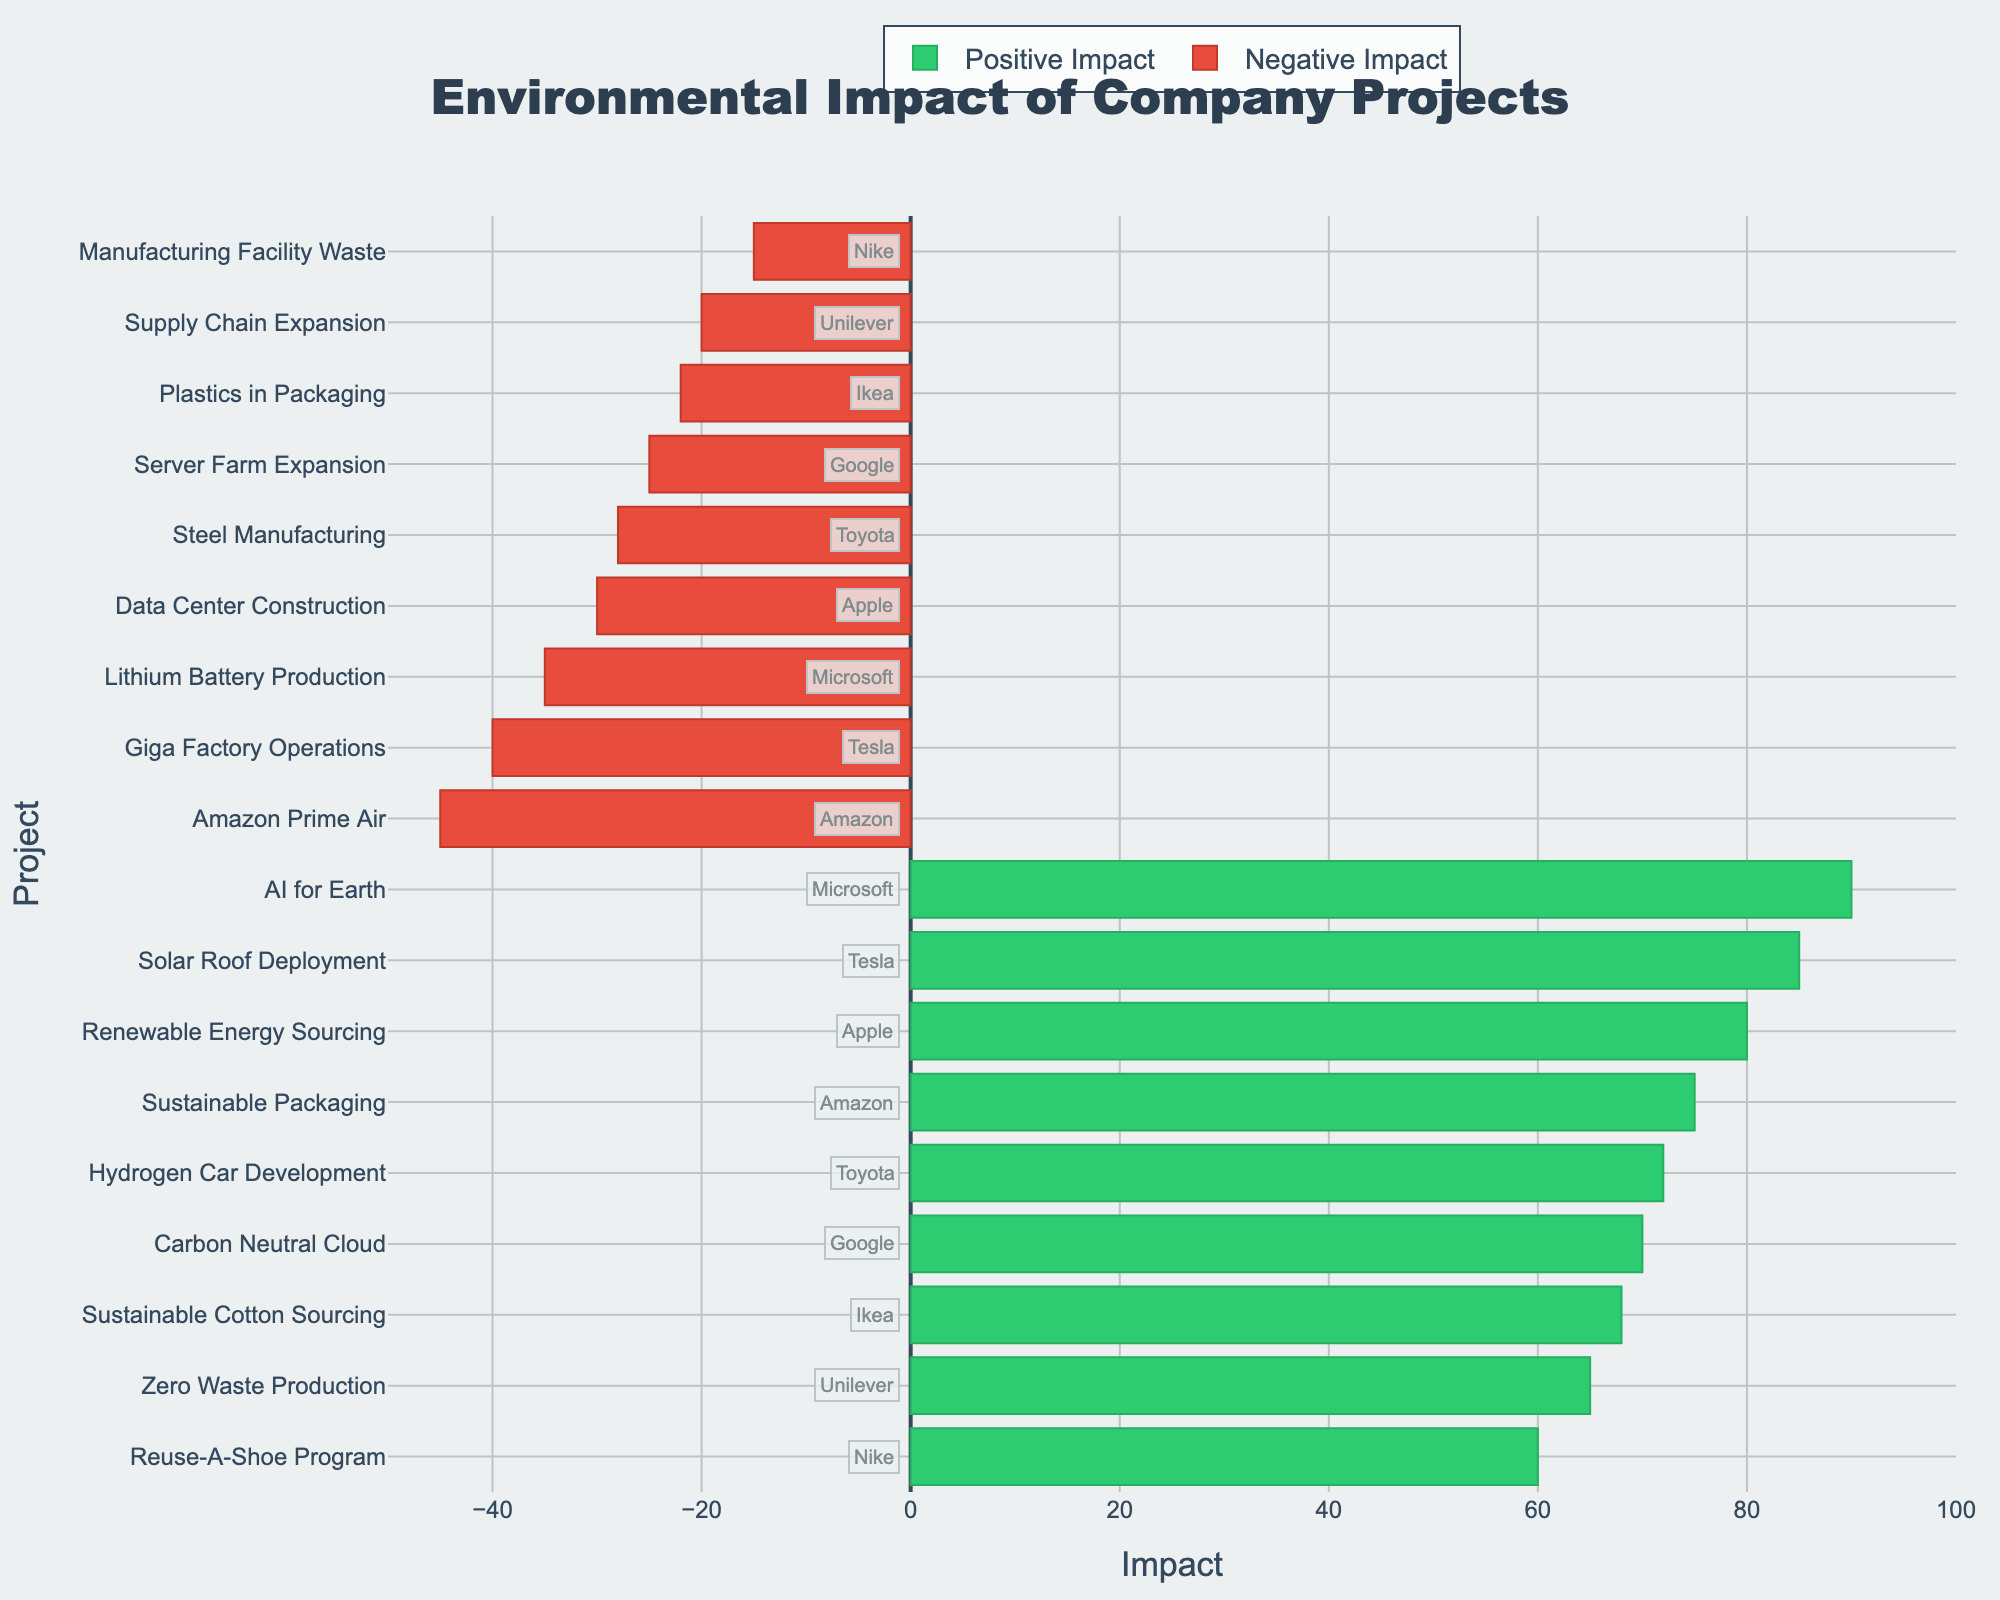Which company has the highest positive environmental impact? To find the company with the highest positive impact, look for the green bar that extends the furthest to the right. Microsoft with the "AI for Earth" project has the highest positive impact with a score of 90.
Answer: Microsoft Which project has the highest negative environmental impact, and what is its impact value? Identify the red bar that extends the furthest to the left, indicating the highest negative impact. "Amazon Prime Air" by Amazon has the highest negative impact with a value of -45.
Answer: Amazon Prime Air, -45 What's the total positive impact value for Apple's projects? Sum the positive impact values for Apple's projects. Apple has only one positive project, "Renewable Energy Sourcing" with an impact value of 80.
Answer: 80 Compare the positive impact of Google's "Carbon Neutral Cloud" to the negative impact of Google's "Server Farm Expansion". Which has a greater magnitude and by how much? The positive impact of "Carbon Neutral Cloud" is 70, while the negative impact of "Server Farm Expansion" is 25 (considering the magnitude). The positive impact is greater. 70 - 25 = 45. The magnitude difference is 45.
Answer: Positive by 45 Which company's projects are closest to a neutral environmental impact? To identify the company with projects closest to a neutral impact, locate bars near the origin (0) on both the positive and negative sides. Nike has "Reuse-A-Shoe Program" at 60 and "Manufacturing Facility Waste" at -15, summing to a smaller net change, indicating closeness to neutrality.
Answer: Nike Among all negative impact projects, what is the average negative impact value? Sum up all negative impact values and divide by the number of negative projects. The values are -30, -25, -35, -40, -45, -20, -15, and -28. Sum = -238. There are 8 negative projects, so average = -238 / 8 = -29.75.
Answer: -29.75 Are there any companies where both their positive and negative impact projects are above or below average in their respective categories? Calculate the average for both positive (sum values and divide by count) and negative impacts. Check if any company’s projects lie consistently above or below these averages. The positive average is calculated above (73.2), negative (-29.75). No single company has both positive and negative values above or below these averages.
Answer: No Which project has the smallest difference in impact value between positive and negative impacts of the same company? Calculate the absolute difference between the positive and negative impacts for each company and identify the smallest. Apple: 80 - (-30) = 110, Google: 70 - (-25) = 95, Microsoft: 90 - (-35) = 125, Tesla: 85 - (-40) = 125, Amazon: 75 - (-45) = 120, Unilever: 65 - (-20) = 85, Nike: 60 - (-15) = 75, Toyota: 72 - (-28) = 100, Ikea: 68 - (-22) = 90. Nike has the smallest difference, 75.
Answer: Reuse-A-Shoe Program and Manufacturing Facility Waste 